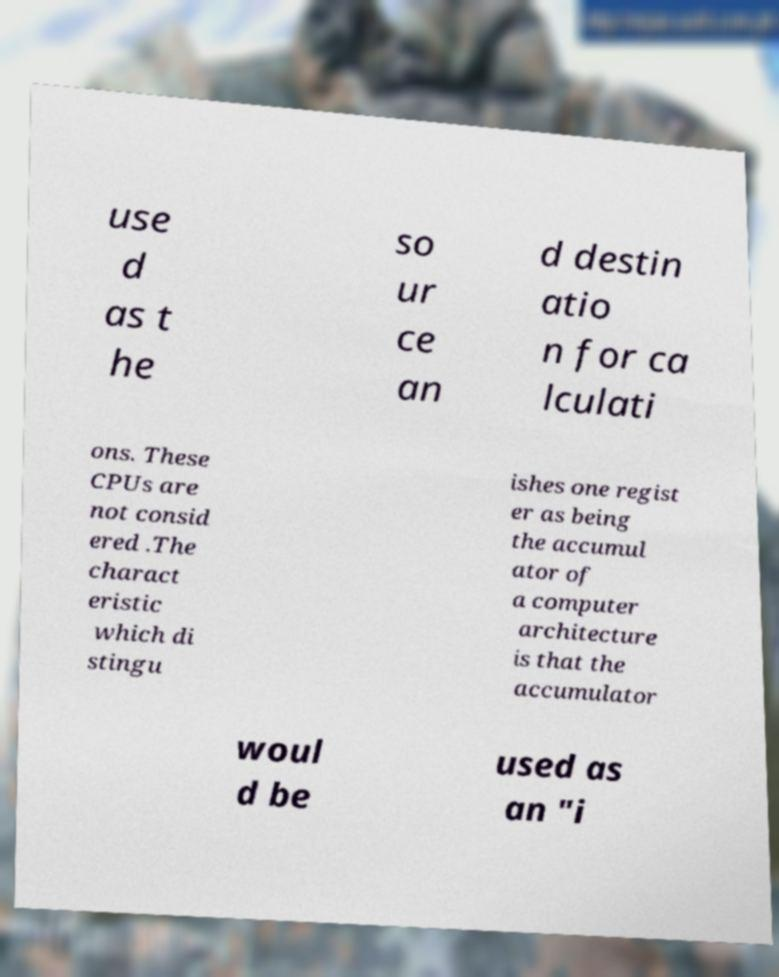I need the written content from this picture converted into text. Can you do that? use d as t he so ur ce an d destin atio n for ca lculati ons. These CPUs are not consid ered .The charact eristic which di stingu ishes one regist er as being the accumul ator of a computer architecture is that the accumulator woul d be used as an "i 